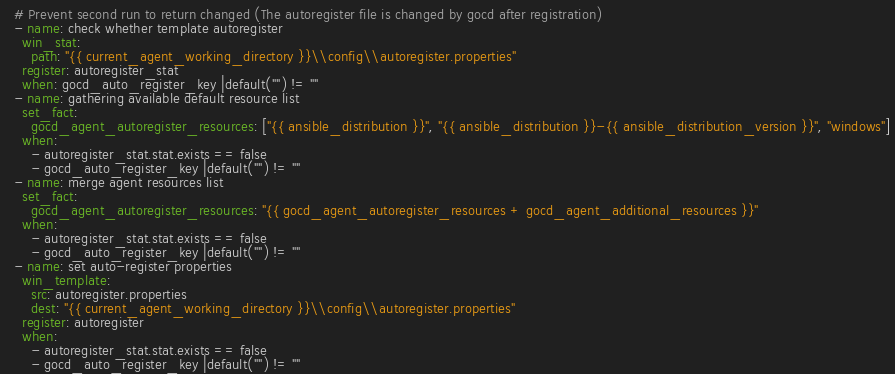<code> <loc_0><loc_0><loc_500><loc_500><_YAML_>  # Prevent second run to return changed (The autoregister file is changed by gocd after registration)
  - name: check whether template autoregister
    win_stat:
      path: "{{ current_agent_working_directory }}\\config\\autoregister.properties"
    register: autoregister_stat
    when: gocd_auto_register_key |default("") != ""
  - name: gathering available default resource list
    set_fact:
      gocd_agent_autoregister_resources: ["{{ ansible_distribution }}", "{{ ansible_distribution }}-{{ ansible_distribution_version }}", "windows"]
    when: 
      - autoregister_stat.stat.exists == false
      - gocd_auto_register_key |default("") != ""
  - name: merge agent resources list
    set_fact:
      gocd_agent_autoregister_resources: "{{ gocd_agent_autoregister_resources + gocd_agent_additional_resources }}"
    when:
      - autoregister_stat.stat.exists == false
      - gocd_auto_register_key |default("") != ""
  - name: set auto-register properties
    win_template:
      src: autoregister.properties
      dest: "{{ current_agent_working_directory }}\\config\\autoregister.properties"
    register: autoregister
    when:
      - autoregister_stat.stat.exists == false
      - gocd_auto_register_key |default("") != ""</code> 